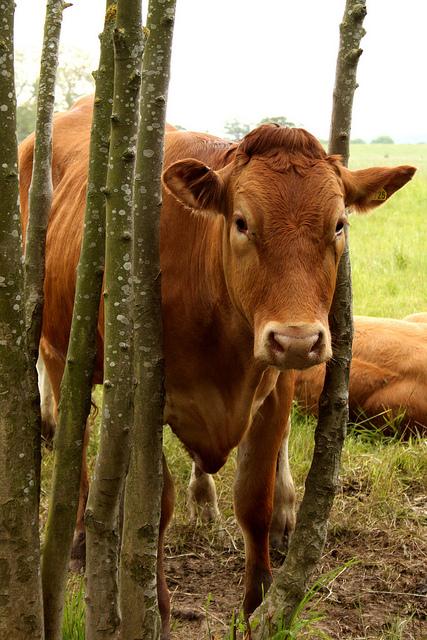Is the cow stuck in a tree?
Answer briefly. No. Which animal is this?
Short answer required. Cow. Are both animals standing?
Answer briefly. No. What color is the cows face?
Answer briefly. Brown. Does the cow have horns?
Quick response, please. No. 